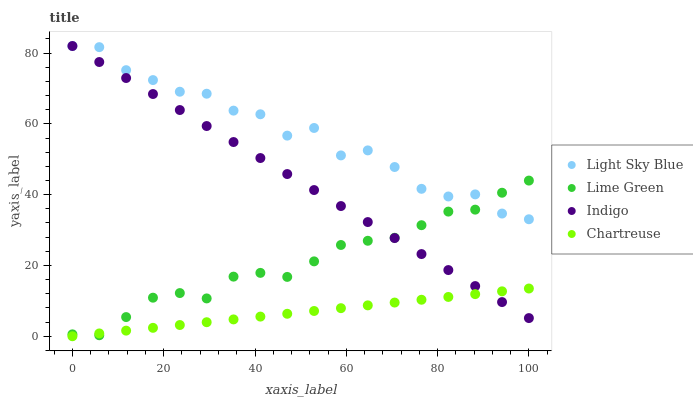Does Chartreuse have the minimum area under the curve?
Answer yes or no. Yes. Does Light Sky Blue have the maximum area under the curve?
Answer yes or no. Yes. Does Light Sky Blue have the minimum area under the curve?
Answer yes or no. No. Does Chartreuse have the maximum area under the curve?
Answer yes or no. No. Is Chartreuse the smoothest?
Answer yes or no. Yes. Is Light Sky Blue the roughest?
Answer yes or no. Yes. Is Light Sky Blue the smoothest?
Answer yes or no. No. Is Chartreuse the roughest?
Answer yes or no. No. Does Chartreuse have the lowest value?
Answer yes or no. Yes. Does Light Sky Blue have the lowest value?
Answer yes or no. No. Does Light Sky Blue have the highest value?
Answer yes or no. Yes. Does Chartreuse have the highest value?
Answer yes or no. No. Is Chartreuse less than Light Sky Blue?
Answer yes or no. Yes. Is Light Sky Blue greater than Chartreuse?
Answer yes or no. Yes. Does Light Sky Blue intersect Indigo?
Answer yes or no. Yes. Is Light Sky Blue less than Indigo?
Answer yes or no. No. Is Light Sky Blue greater than Indigo?
Answer yes or no. No. Does Chartreuse intersect Light Sky Blue?
Answer yes or no. No. 